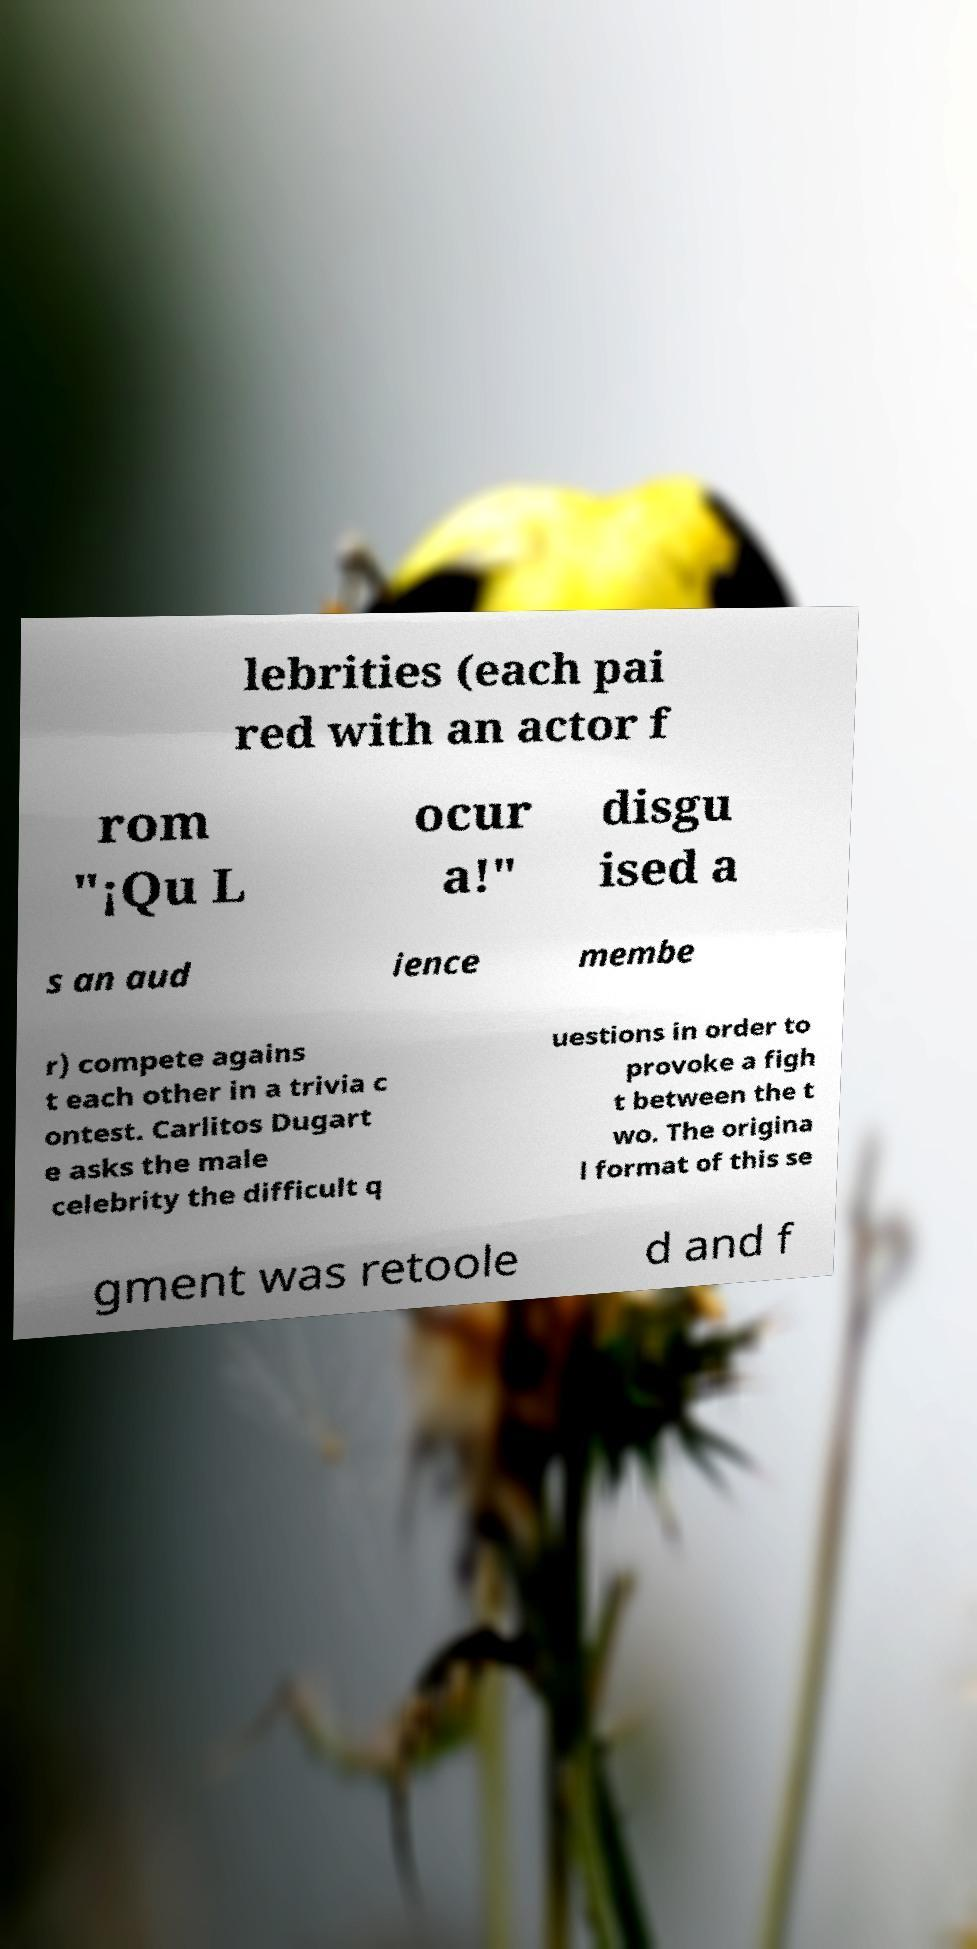I need the written content from this picture converted into text. Can you do that? lebrities (each pai red with an actor f rom "¡Qu L ocur a!" disgu ised a s an aud ience membe r) compete agains t each other in a trivia c ontest. Carlitos Dugart e asks the male celebrity the difficult q uestions in order to provoke a figh t between the t wo. The origina l format of this se gment was retoole d and f 